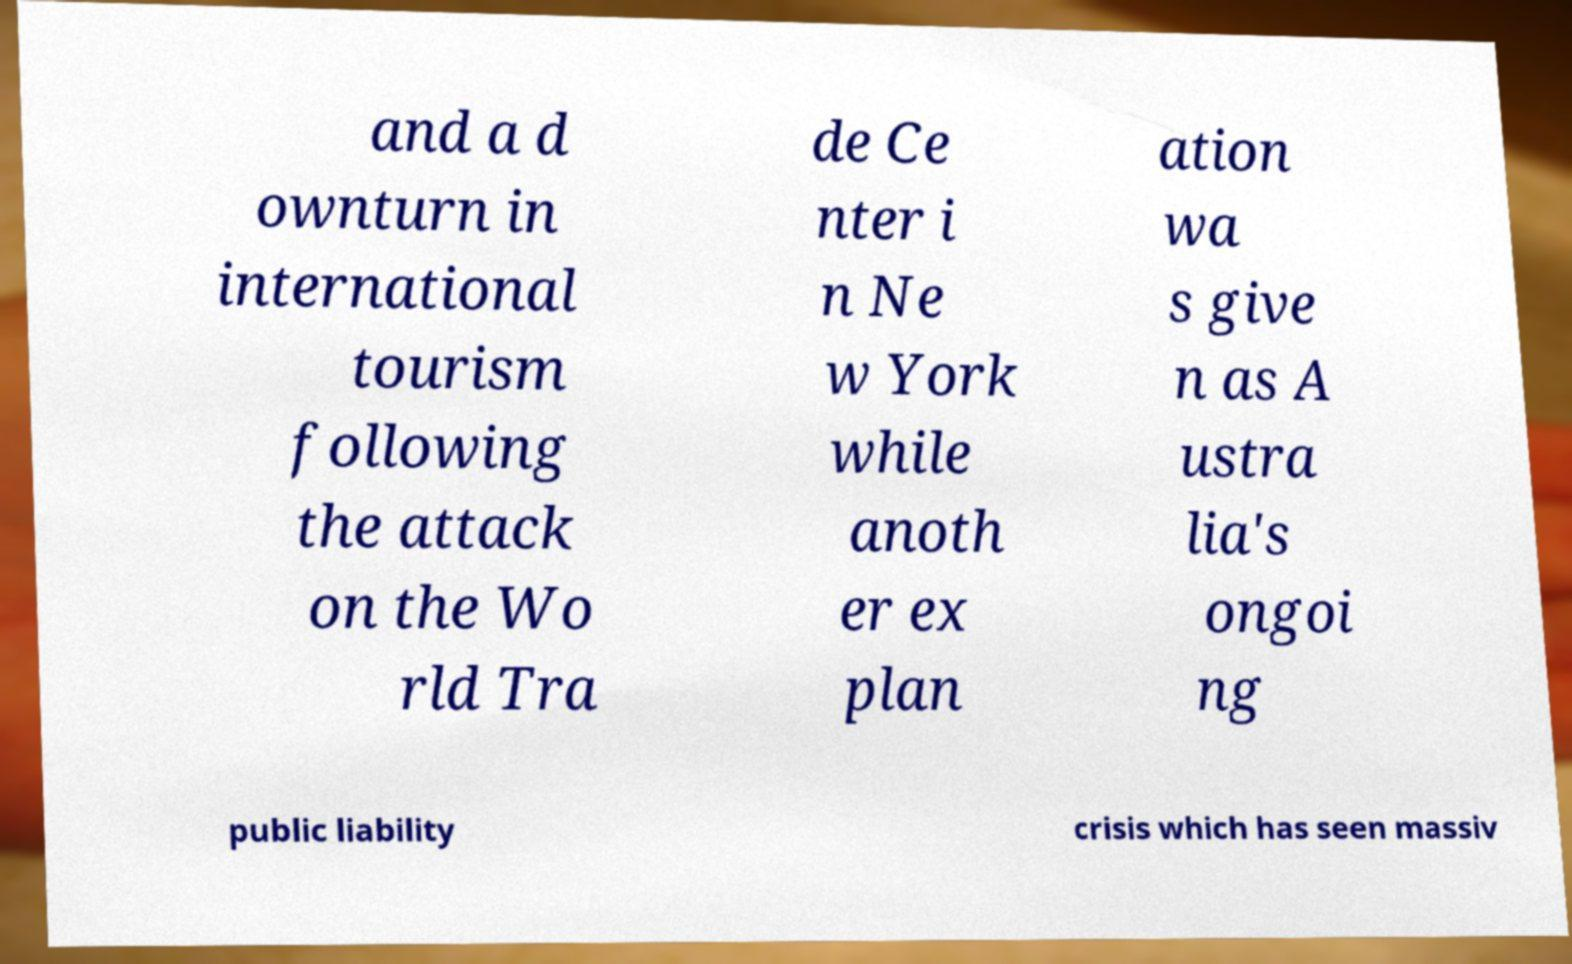For documentation purposes, I need the text within this image transcribed. Could you provide that? and a d ownturn in international tourism following the attack on the Wo rld Tra de Ce nter i n Ne w York while anoth er ex plan ation wa s give n as A ustra lia's ongoi ng public liability crisis which has seen massiv 